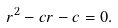Convert formula to latex. <formula><loc_0><loc_0><loc_500><loc_500>r ^ { 2 } - c r - c = 0 .</formula> 